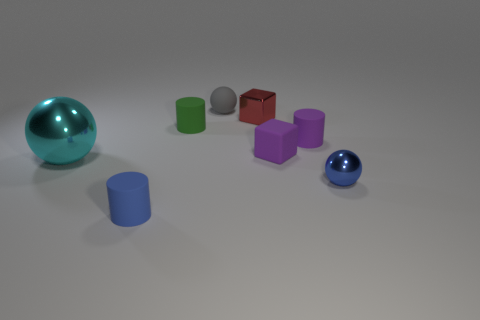Add 2 tiny purple metallic balls. How many objects exist? 10 Subtract all cubes. How many objects are left? 6 Subtract 0 gray cubes. How many objects are left? 8 Subtract all large purple balls. Subtract all gray objects. How many objects are left? 7 Add 6 tiny blue things. How many tiny blue things are left? 8 Add 1 purple rubber cylinders. How many purple rubber cylinders exist? 2 